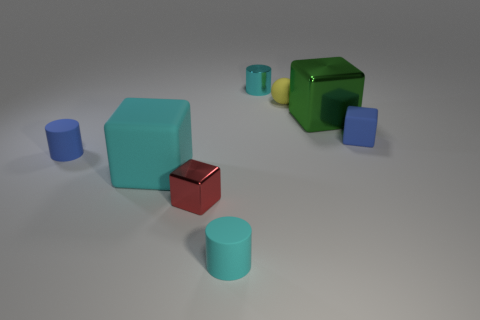There is a rubber cylinder that is the same color as the big rubber thing; what size is it?
Provide a succinct answer. Small. How many small matte objects are right of the cyan block and in front of the blue matte cube?
Offer a terse response. 1. Is the material of the small red cube the same as the large block that is to the left of the cyan metal cylinder?
Give a very brief answer. No. Is the number of small yellow matte balls in front of the tiny blue rubber cylinder the same as the number of blue matte spheres?
Keep it short and to the point. Yes. There is a tiny shiny object in front of the yellow rubber sphere; what is its color?
Make the answer very short. Red. How many other objects are there of the same color as the tiny metal cube?
Ensure brevity in your answer.  0. Does the shiny object that is in front of the blue matte cube have the same size as the ball?
Your answer should be compact. Yes. What material is the big cube that is right of the tiny yellow object?
Your response must be concise. Metal. Are there any other things that are the same shape as the small yellow thing?
Provide a succinct answer. No. What number of rubber objects are either small yellow balls or blue things?
Provide a short and direct response. 3. 